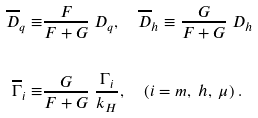Convert formula to latex. <formula><loc_0><loc_0><loc_500><loc_500>\overline { D } _ { q } \equiv & \frac { F } { F + G } \ D _ { q } , \quad \overline { D } _ { h } \equiv \frac { G } { F + G } \ D _ { h } \\ & \\ \overline { \Gamma } _ { i } \equiv & \frac { G } { F + G } \ \frac { \Gamma _ { i } } { k _ { H } } , \quad ( i = m , \ h , \ \mu ) \ .</formula> 